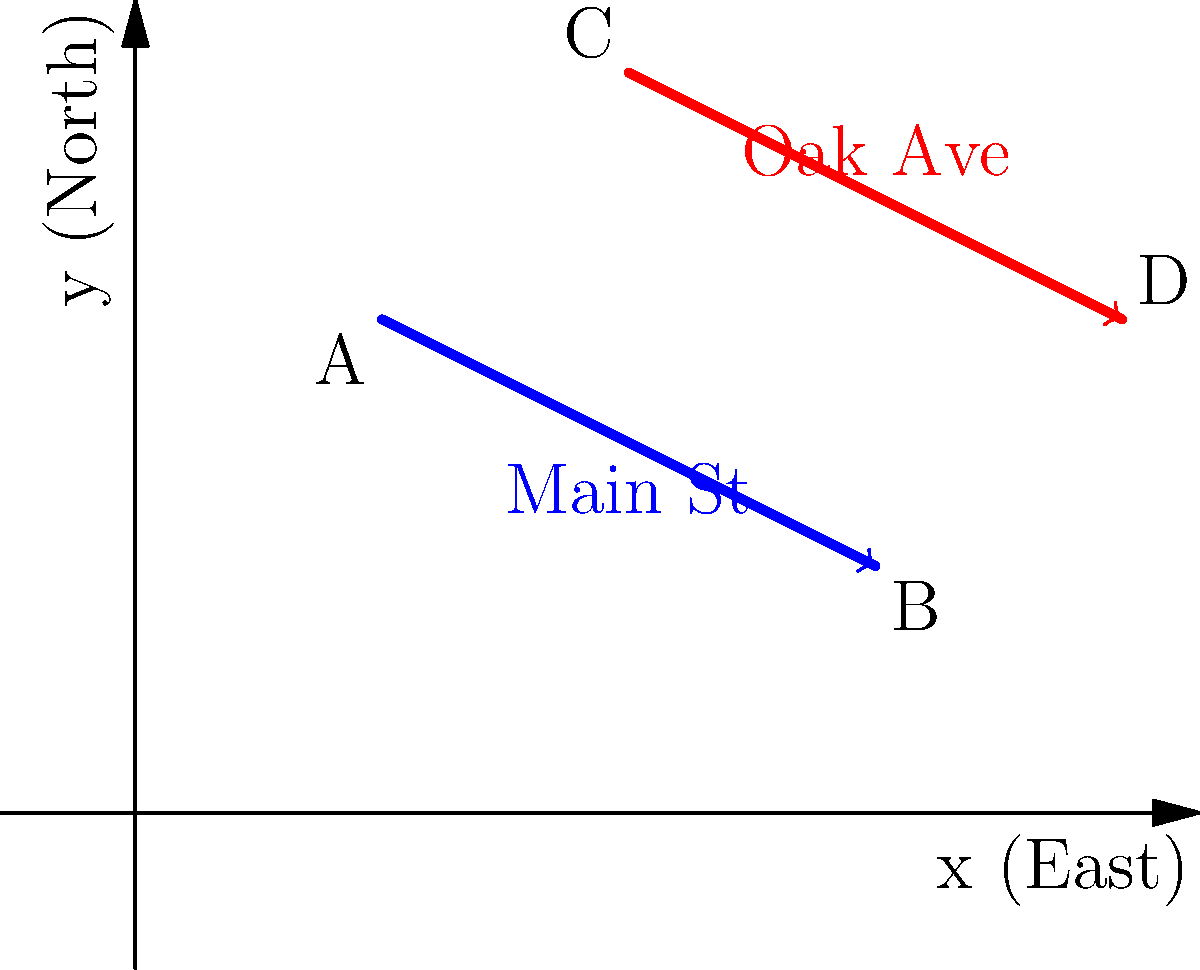As a developer planning a new project, you need to analyze traffic flow patterns at a key intersection. The diagram shows two roads: Main St (blue) and Oak Ave (red), represented in a coordinate system where each unit equals 100 meters. Main St runs from point A(1,2) to B(3,1), while Oak Ave runs from C(2,3) to D(4,2). Calculate the angle of intersection between these two roads to determine if any modifications are needed for improved traffic flow. Round your answer to the nearest degree. To find the angle of intersection between Main St and Oak Ave, we'll follow these steps:

1. Calculate the direction vectors of both roads:
   Main St vector: $\vec{v_1} = B - A = (3-1, 1-2) = (2, -1)$
   Oak Ave vector: $\vec{v_2} = D - C = (4-2, 2-3) = (2, -1)$

2. Use the dot product formula to find the angle between the vectors:
   $\cos \theta = \frac{\vec{v_1} \cdot \vec{v_2}}{|\vec{v_1}||\vec{v_2}|}$

3. Calculate the dot product:
   $\vec{v_1} \cdot \vec{v_2} = (2)(2) + (-1)(-1) = 4 + 1 = 5$

4. Calculate the magnitudes:
   $|\vec{v_1}| = \sqrt{2^2 + (-1)^2} = \sqrt{5}$
   $|\vec{v_2}| = \sqrt{2^2 + (-1)^2} = \sqrt{5}$

5. Substitute into the formula:
   $\cos \theta = \frac{5}{\sqrt{5}\sqrt{5}} = \frac{5}{5} = 1$

6. Take the inverse cosine (arccos) to find the angle:
   $\theta = \arccos(1) = 0°$

7. The angle between the roads is 0°, meaning they are parallel. To find the actual intersection angle, we need to subtract this from 180°:
   Intersection angle = $180° - 0° = 180°$

8. Round to the nearest degree: 180°
Answer: 180° 